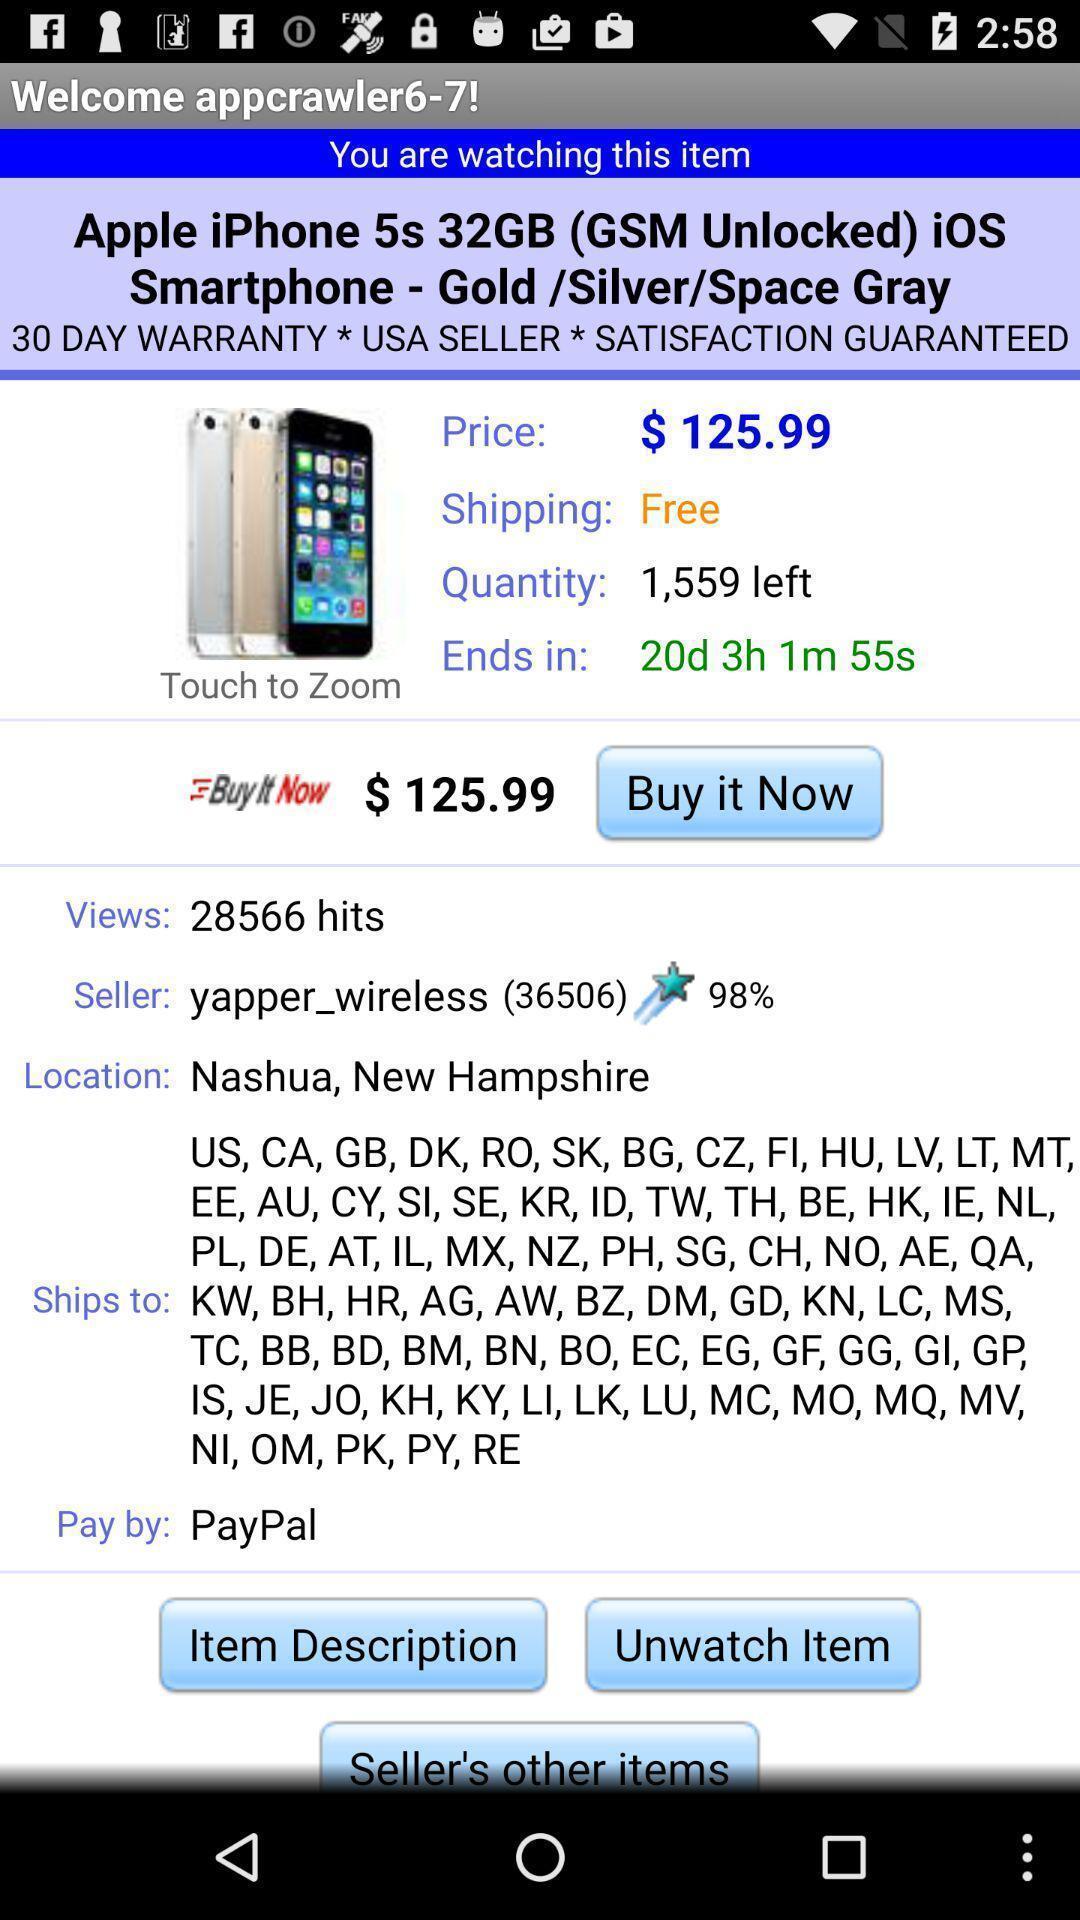Describe the content in this image. Welcome page. 